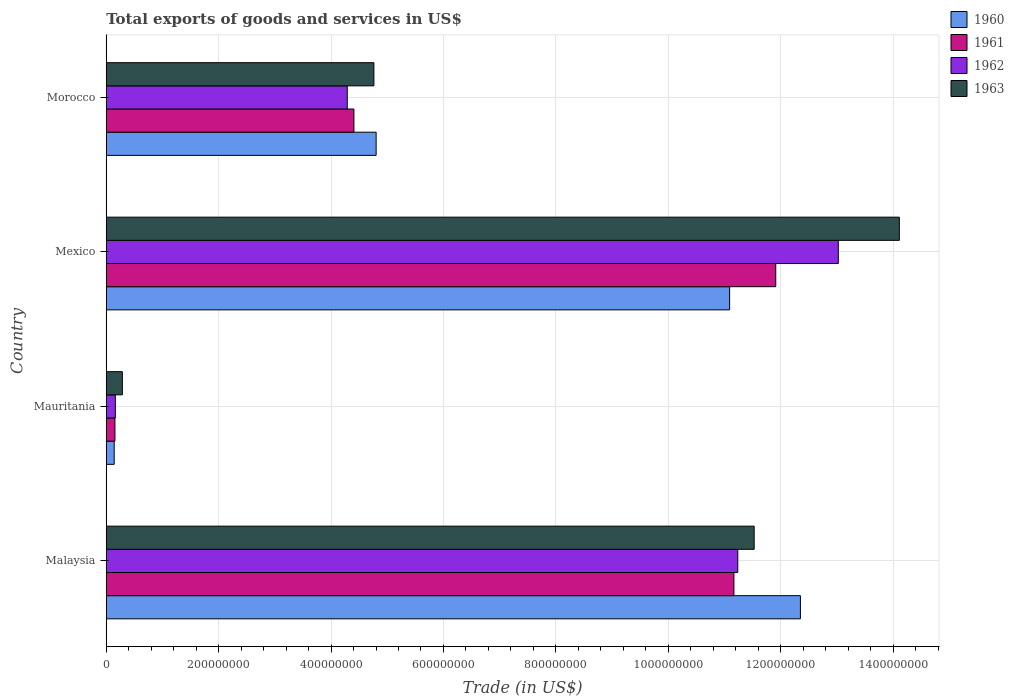How many different coloured bars are there?
Your response must be concise. 4. Are the number of bars per tick equal to the number of legend labels?
Your answer should be compact. Yes. How many bars are there on the 1st tick from the top?
Give a very brief answer. 4. What is the label of the 2nd group of bars from the top?
Give a very brief answer. Mexico. What is the total exports of goods and services in 1961 in Malaysia?
Your answer should be compact. 1.12e+09. Across all countries, what is the maximum total exports of goods and services in 1962?
Provide a succinct answer. 1.30e+09. Across all countries, what is the minimum total exports of goods and services in 1961?
Keep it short and to the point. 1.54e+07. In which country was the total exports of goods and services in 1961 maximum?
Provide a short and direct response. Mexico. In which country was the total exports of goods and services in 1963 minimum?
Your answer should be very brief. Mauritania. What is the total total exports of goods and services in 1961 in the graph?
Provide a short and direct response. 2.76e+09. What is the difference between the total exports of goods and services in 1963 in Malaysia and that in Mexico?
Provide a short and direct response. -2.58e+08. What is the difference between the total exports of goods and services in 1960 in Morocco and the total exports of goods and services in 1963 in Malaysia?
Give a very brief answer. -6.73e+08. What is the average total exports of goods and services in 1961 per country?
Your answer should be compact. 6.91e+08. What is the difference between the total exports of goods and services in 1962 and total exports of goods and services in 1960 in Mexico?
Offer a terse response. 1.93e+08. In how many countries, is the total exports of goods and services in 1962 greater than 1400000000 US$?
Keep it short and to the point. 0. What is the ratio of the total exports of goods and services in 1963 in Mexico to that in Morocco?
Give a very brief answer. 2.96. Is the difference between the total exports of goods and services in 1962 in Mauritania and Mexico greater than the difference between the total exports of goods and services in 1960 in Mauritania and Mexico?
Provide a short and direct response. No. What is the difference between the highest and the second highest total exports of goods and services in 1962?
Your answer should be compact. 1.79e+08. What is the difference between the highest and the lowest total exports of goods and services in 1961?
Offer a terse response. 1.18e+09. Is the sum of the total exports of goods and services in 1961 in Mexico and Morocco greater than the maximum total exports of goods and services in 1963 across all countries?
Keep it short and to the point. Yes. Is it the case that in every country, the sum of the total exports of goods and services in 1962 and total exports of goods and services in 1963 is greater than the sum of total exports of goods and services in 1961 and total exports of goods and services in 1960?
Offer a very short reply. No. What does the 4th bar from the top in Malaysia represents?
Your answer should be very brief. 1960. What does the 1st bar from the bottom in Malaysia represents?
Your answer should be compact. 1960. Is it the case that in every country, the sum of the total exports of goods and services in 1963 and total exports of goods and services in 1961 is greater than the total exports of goods and services in 1962?
Provide a short and direct response. Yes. How many bars are there?
Provide a succinct answer. 16. Are all the bars in the graph horizontal?
Your response must be concise. Yes. How many countries are there in the graph?
Provide a succinct answer. 4. Does the graph contain grids?
Your response must be concise. Yes. How many legend labels are there?
Make the answer very short. 4. How are the legend labels stacked?
Your answer should be compact. Vertical. What is the title of the graph?
Ensure brevity in your answer.  Total exports of goods and services in US$. Does "2005" appear as one of the legend labels in the graph?
Your response must be concise. No. What is the label or title of the X-axis?
Keep it short and to the point. Trade (in US$). What is the label or title of the Y-axis?
Provide a succinct answer. Country. What is the Trade (in US$) of 1960 in Malaysia?
Provide a succinct answer. 1.24e+09. What is the Trade (in US$) of 1961 in Malaysia?
Your response must be concise. 1.12e+09. What is the Trade (in US$) in 1962 in Malaysia?
Keep it short and to the point. 1.12e+09. What is the Trade (in US$) in 1963 in Malaysia?
Your answer should be very brief. 1.15e+09. What is the Trade (in US$) of 1960 in Mauritania?
Give a very brief answer. 1.41e+07. What is the Trade (in US$) in 1961 in Mauritania?
Your answer should be very brief. 1.54e+07. What is the Trade (in US$) in 1962 in Mauritania?
Provide a short and direct response. 1.62e+07. What is the Trade (in US$) in 1963 in Mauritania?
Offer a terse response. 2.87e+07. What is the Trade (in US$) of 1960 in Mexico?
Make the answer very short. 1.11e+09. What is the Trade (in US$) of 1961 in Mexico?
Provide a short and direct response. 1.19e+09. What is the Trade (in US$) of 1962 in Mexico?
Provide a succinct answer. 1.30e+09. What is the Trade (in US$) in 1963 in Mexico?
Provide a succinct answer. 1.41e+09. What is the Trade (in US$) in 1960 in Morocco?
Your answer should be very brief. 4.80e+08. What is the Trade (in US$) in 1961 in Morocco?
Provide a short and direct response. 4.41e+08. What is the Trade (in US$) of 1962 in Morocco?
Offer a terse response. 4.29e+08. What is the Trade (in US$) in 1963 in Morocco?
Keep it short and to the point. 4.76e+08. Across all countries, what is the maximum Trade (in US$) in 1960?
Provide a short and direct response. 1.24e+09. Across all countries, what is the maximum Trade (in US$) of 1961?
Ensure brevity in your answer.  1.19e+09. Across all countries, what is the maximum Trade (in US$) of 1962?
Provide a succinct answer. 1.30e+09. Across all countries, what is the maximum Trade (in US$) in 1963?
Make the answer very short. 1.41e+09. Across all countries, what is the minimum Trade (in US$) in 1960?
Your answer should be compact. 1.41e+07. Across all countries, what is the minimum Trade (in US$) of 1961?
Keep it short and to the point. 1.54e+07. Across all countries, what is the minimum Trade (in US$) in 1962?
Your response must be concise. 1.62e+07. Across all countries, what is the minimum Trade (in US$) in 1963?
Your answer should be very brief. 2.87e+07. What is the total Trade (in US$) of 1960 in the graph?
Keep it short and to the point. 2.84e+09. What is the total Trade (in US$) in 1961 in the graph?
Offer a very short reply. 2.76e+09. What is the total Trade (in US$) in 1962 in the graph?
Keep it short and to the point. 2.87e+09. What is the total Trade (in US$) of 1963 in the graph?
Ensure brevity in your answer.  3.07e+09. What is the difference between the Trade (in US$) of 1960 in Malaysia and that in Mauritania?
Your response must be concise. 1.22e+09. What is the difference between the Trade (in US$) of 1961 in Malaysia and that in Mauritania?
Provide a succinct answer. 1.10e+09. What is the difference between the Trade (in US$) of 1962 in Malaysia and that in Mauritania?
Provide a short and direct response. 1.11e+09. What is the difference between the Trade (in US$) in 1963 in Malaysia and that in Mauritania?
Your answer should be very brief. 1.12e+09. What is the difference between the Trade (in US$) in 1960 in Malaysia and that in Mexico?
Make the answer very short. 1.26e+08. What is the difference between the Trade (in US$) of 1961 in Malaysia and that in Mexico?
Ensure brevity in your answer.  -7.44e+07. What is the difference between the Trade (in US$) in 1962 in Malaysia and that in Mexico?
Offer a terse response. -1.79e+08. What is the difference between the Trade (in US$) in 1963 in Malaysia and that in Mexico?
Your answer should be very brief. -2.58e+08. What is the difference between the Trade (in US$) of 1960 in Malaysia and that in Morocco?
Offer a terse response. 7.55e+08. What is the difference between the Trade (in US$) of 1961 in Malaysia and that in Morocco?
Your answer should be compact. 6.76e+08. What is the difference between the Trade (in US$) of 1962 in Malaysia and that in Morocco?
Keep it short and to the point. 6.95e+08. What is the difference between the Trade (in US$) of 1963 in Malaysia and that in Morocco?
Provide a short and direct response. 6.77e+08. What is the difference between the Trade (in US$) of 1960 in Mauritania and that in Mexico?
Keep it short and to the point. -1.09e+09. What is the difference between the Trade (in US$) in 1961 in Mauritania and that in Mexico?
Your answer should be very brief. -1.18e+09. What is the difference between the Trade (in US$) in 1962 in Mauritania and that in Mexico?
Provide a succinct answer. -1.29e+09. What is the difference between the Trade (in US$) of 1963 in Mauritania and that in Mexico?
Make the answer very short. -1.38e+09. What is the difference between the Trade (in US$) in 1960 in Mauritania and that in Morocco?
Provide a succinct answer. -4.66e+08. What is the difference between the Trade (in US$) of 1961 in Mauritania and that in Morocco?
Your response must be concise. -4.25e+08. What is the difference between the Trade (in US$) in 1962 in Mauritania and that in Morocco?
Give a very brief answer. -4.13e+08. What is the difference between the Trade (in US$) of 1963 in Mauritania and that in Morocco?
Offer a very short reply. -4.48e+08. What is the difference between the Trade (in US$) in 1960 in Mexico and that in Morocco?
Your response must be concise. 6.29e+08. What is the difference between the Trade (in US$) in 1961 in Mexico and that in Morocco?
Your response must be concise. 7.51e+08. What is the difference between the Trade (in US$) in 1962 in Mexico and that in Morocco?
Make the answer very short. 8.74e+08. What is the difference between the Trade (in US$) in 1963 in Mexico and that in Morocco?
Ensure brevity in your answer.  9.35e+08. What is the difference between the Trade (in US$) in 1960 in Malaysia and the Trade (in US$) in 1961 in Mauritania?
Your answer should be very brief. 1.22e+09. What is the difference between the Trade (in US$) in 1960 in Malaysia and the Trade (in US$) in 1962 in Mauritania?
Make the answer very short. 1.22e+09. What is the difference between the Trade (in US$) of 1960 in Malaysia and the Trade (in US$) of 1963 in Mauritania?
Give a very brief answer. 1.21e+09. What is the difference between the Trade (in US$) in 1961 in Malaysia and the Trade (in US$) in 1962 in Mauritania?
Offer a very short reply. 1.10e+09. What is the difference between the Trade (in US$) of 1961 in Malaysia and the Trade (in US$) of 1963 in Mauritania?
Give a very brief answer. 1.09e+09. What is the difference between the Trade (in US$) in 1962 in Malaysia and the Trade (in US$) in 1963 in Mauritania?
Your answer should be very brief. 1.09e+09. What is the difference between the Trade (in US$) in 1960 in Malaysia and the Trade (in US$) in 1961 in Mexico?
Provide a short and direct response. 4.39e+07. What is the difference between the Trade (in US$) in 1960 in Malaysia and the Trade (in US$) in 1962 in Mexico?
Offer a terse response. -6.74e+07. What is the difference between the Trade (in US$) of 1960 in Malaysia and the Trade (in US$) of 1963 in Mexico?
Give a very brief answer. -1.76e+08. What is the difference between the Trade (in US$) of 1961 in Malaysia and the Trade (in US$) of 1962 in Mexico?
Provide a short and direct response. -1.86e+08. What is the difference between the Trade (in US$) of 1961 in Malaysia and the Trade (in US$) of 1963 in Mexico?
Give a very brief answer. -2.94e+08. What is the difference between the Trade (in US$) of 1962 in Malaysia and the Trade (in US$) of 1963 in Mexico?
Ensure brevity in your answer.  -2.87e+08. What is the difference between the Trade (in US$) of 1960 in Malaysia and the Trade (in US$) of 1961 in Morocco?
Make the answer very short. 7.94e+08. What is the difference between the Trade (in US$) of 1960 in Malaysia and the Trade (in US$) of 1962 in Morocco?
Give a very brief answer. 8.06e+08. What is the difference between the Trade (in US$) in 1960 in Malaysia and the Trade (in US$) in 1963 in Morocco?
Make the answer very short. 7.59e+08. What is the difference between the Trade (in US$) in 1961 in Malaysia and the Trade (in US$) in 1962 in Morocco?
Keep it short and to the point. 6.88e+08. What is the difference between the Trade (in US$) of 1961 in Malaysia and the Trade (in US$) of 1963 in Morocco?
Provide a short and direct response. 6.41e+08. What is the difference between the Trade (in US$) in 1962 in Malaysia and the Trade (in US$) in 1963 in Morocco?
Offer a very short reply. 6.47e+08. What is the difference between the Trade (in US$) in 1960 in Mauritania and the Trade (in US$) in 1961 in Mexico?
Keep it short and to the point. -1.18e+09. What is the difference between the Trade (in US$) in 1960 in Mauritania and the Trade (in US$) in 1962 in Mexico?
Your answer should be compact. -1.29e+09. What is the difference between the Trade (in US$) of 1960 in Mauritania and the Trade (in US$) of 1963 in Mexico?
Make the answer very short. -1.40e+09. What is the difference between the Trade (in US$) of 1961 in Mauritania and the Trade (in US$) of 1962 in Mexico?
Provide a succinct answer. -1.29e+09. What is the difference between the Trade (in US$) in 1961 in Mauritania and the Trade (in US$) in 1963 in Mexico?
Keep it short and to the point. -1.40e+09. What is the difference between the Trade (in US$) of 1962 in Mauritania and the Trade (in US$) of 1963 in Mexico?
Provide a short and direct response. -1.39e+09. What is the difference between the Trade (in US$) in 1960 in Mauritania and the Trade (in US$) in 1961 in Morocco?
Make the answer very short. -4.27e+08. What is the difference between the Trade (in US$) of 1960 in Mauritania and the Trade (in US$) of 1962 in Morocco?
Keep it short and to the point. -4.15e+08. What is the difference between the Trade (in US$) of 1960 in Mauritania and the Trade (in US$) of 1963 in Morocco?
Provide a short and direct response. -4.62e+08. What is the difference between the Trade (in US$) in 1961 in Mauritania and the Trade (in US$) in 1962 in Morocco?
Make the answer very short. -4.13e+08. What is the difference between the Trade (in US$) in 1961 in Mauritania and the Trade (in US$) in 1963 in Morocco?
Ensure brevity in your answer.  -4.61e+08. What is the difference between the Trade (in US$) of 1962 in Mauritania and the Trade (in US$) of 1963 in Morocco?
Your answer should be very brief. -4.60e+08. What is the difference between the Trade (in US$) of 1960 in Mexico and the Trade (in US$) of 1961 in Morocco?
Make the answer very short. 6.68e+08. What is the difference between the Trade (in US$) of 1960 in Mexico and the Trade (in US$) of 1962 in Morocco?
Make the answer very short. 6.80e+08. What is the difference between the Trade (in US$) in 1960 in Mexico and the Trade (in US$) in 1963 in Morocco?
Your response must be concise. 6.33e+08. What is the difference between the Trade (in US$) in 1961 in Mexico and the Trade (in US$) in 1962 in Morocco?
Your response must be concise. 7.62e+08. What is the difference between the Trade (in US$) of 1961 in Mexico and the Trade (in US$) of 1963 in Morocco?
Keep it short and to the point. 7.15e+08. What is the difference between the Trade (in US$) in 1962 in Mexico and the Trade (in US$) in 1963 in Morocco?
Your answer should be compact. 8.26e+08. What is the average Trade (in US$) of 1960 per country?
Give a very brief answer. 7.10e+08. What is the average Trade (in US$) of 1961 per country?
Your answer should be compact. 6.91e+08. What is the average Trade (in US$) in 1962 per country?
Offer a very short reply. 7.18e+08. What is the average Trade (in US$) in 1963 per country?
Ensure brevity in your answer.  7.67e+08. What is the difference between the Trade (in US$) of 1960 and Trade (in US$) of 1961 in Malaysia?
Give a very brief answer. 1.18e+08. What is the difference between the Trade (in US$) in 1960 and Trade (in US$) in 1962 in Malaysia?
Provide a succinct answer. 1.11e+08. What is the difference between the Trade (in US$) of 1960 and Trade (in US$) of 1963 in Malaysia?
Keep it short and to the point. 8.23e+07. What is the difference between the Trade (in US$) of 1961 and Trade (in US$) of 1962 in Malaysia?
Provide a succinct answer. -6.88e+06. What is the difference between the Trade (in US$) in 1961 and Trade (in US$) in 1963 in Malaysia?
Offer a terse response. -3.60e+07. What is the difference between the Trade (in US$) of 1962 and Trade (in US$) of 1963 in Malaysia?
Make the answer very short. -2.92e+07. What is the difference between the Trade (in US$) in 1960 and Trade (in US$) in 1961 in Mauritania?
Give a very brief answer. -1.31e+06. What is the difference between the Trade (in US$) of 1960 and Trade (in US$) of 1962 in Mauritania?
Give a very brief answer. -2.02e+06. What is the difference between the Trade (in US$) of 1960 and Trade (in US$) of 1963 in Mauritania?
Keep it short and to the point. -1.45e+07. What is the difference between the Trade (in US$) of 1961 and Trade (in US$) of 1962 in Mauritania?
Provide a short and direct response. -7.07e+05. What is the difference between the Trade (in US$) in 1961 and Trade (in US$) in 1963 in Mauritania?
Make the answer very short. -1.32e+07. What is the difference between the Trade (in US$) in 1962 and Trade (in US$) in 1963 in Mauritania?
Offer a terse response. -1.25e+07. What is the difference between the Trade (in US$) of 1960 and Trade (in US$) of 1961 in Mexico?
Keep it short and to the point. -8.21e+07. What is the difference between the Trade (in US$) in 1960 and Trade (in US$) in 1962 in Mexico?
Your answer should be compact. -1.93e+08. What is the difference between the Trade (in US$) of 1960 and Trade (in US$) of 1963 in Mexico?
Offer a terse response. -3.02e+08. What is the difference between the Trade (in US$) of 1961 and Trade (in US$) of 1962 in Mexico?
Your answer should be compact. -1.11e+08. What is the difference between the Trade (in US$) of 1961 and Trade (in US$) of 1963 in Mexico?
Your answer should be very brief. -2.20e+08. What is the difference between the Trade (in US$) in 1962 and Trade (in US$) in 1963 in Mexico?
Ensure brevity in your answer.  -1.09e+08. What is the difference between the Trade (in US$) of 1960 and Trade (in US$) of 1961 in Morocco?
Give a very brief answer. 3.95e+07. What is the difference between the Trade (in US$) in 1960 and Trade (in US$) in 1962 in Morocco?
Provide a short and direct response. 5.14e+07. What is the difference between the Trade (in US$) in 1960 and Trade (in US$) in 1963 in Morocco?
Ensure brevity in your answer.  3.95e+06. What is the difference between the Trade (in US$) in 1961 and Trade (in US$) in 1962 in Morocco?
Give a very brief answer. 1.19e+07. What is the difference between the Trade (in US$) of 1961 and Trade (in US$) of 1963 in Morocco?
Ensure brevity in your answer.  -3.56e+07. What is the difference between the Trade (in US$) of 1962 and Trade (in US$) of 1963 in Morocco?
Ensure brevity in your answer.  -4.74e+07. What is the ratio of the Trade (in US$) in 1960 in Malaysia to that in Mauritania?
Offer a terse response. 87.37. What is the ratio of the Trade (in US$) in 1961 in Malaysia to that in Mauritania?
Make the answer very short. 72.29. What is the ratio of the Trade (in US$) of 1962 in Malaysia to that in Mauritania?
Offer a very short reply. 69.56. What is the ratio of the Trade (in US$) in 1963 in Malaysia to that in Mauritania?
Offer a terse response. 40.2. What is the ratio of the Trade (in US$) in 1960 in Malaysia to that in Mexico?
Offer a terse response. 1.11. What is the ratio of the Trade (in US$) in 1962 in Malaysia to that in Mexico?
Keep it short and to the point. 0.86. What is the ratio of the Trade (in US$) in 1963 in Malaysia to that in Mexico?
Your answer should be compact. 0.82. What is the ratio of the Trade (in US$) in 1960 in Malaysia to that in Morocco?
Offer a very short reply. 2.57. What is the ratio of the Trade (in US$) of 1961 in Malaysia to that in Morocco?
Ensure brevity in your answer.  2.53. What is the ratio of the Trade (in US$) in 1962 in Malaysia to that in Morocco?
Provide a succinct answer. 2.62. What is the ratio of the Trade (in US$) in 1963 in Malaysia to that in Morocco?
Ensure brevity in your answer.  2.42. What is the ratio of the Trade (in US$) in 1960 in Mauritania to that in Mexico?
Your response must be concise. 0.01. What is the ratio of the Trade (in US$) of 1961 in Mauritania to that in Mexico?
Make the answer very short. 0.01. What is the ratio of the Trade (in US$) in 1962 in Mauritania to that in Mexico?
Your answer should be very brief. 0.01. What is the ratio of the Trade (in US$) of 1963 in Mauritania to that in Mexico?
Offer a terse response. 0.02. What is the ratio of the Trade (in US$) of 1960 in Mauritania to that in Morocco?
Offer a very short reply. 0.03. What is the ratio of the Trade (in US$) of 1961 in Mauritania to that in Morocco?
Offer a very short reply. 0.04. What is the ratio of the Trade (in US$) of 1962 in Mauritania to that in Morocco?
Your response must be concise. 0.04. What is the ratio of the Trade (in US$) of 1963 in Mauritania to that in Morocco?
Make the answer very short. 0.06. What is the ratio of the Trade (in US$) in 1960 in Mexico to that in Morocco?
Keep it short and to the point. 2.31. What is the ratio of the Trade (in US$) of 1961 in Mexico to that in Morocco?
Make the answer very short. 2.7. What is the ratio of the Trade (in US$) in 1962 in Mexico to that in Morocco?
Keep it short and to the point. 3.04. What is the ratio of the Trade (in US$) of 1963 in Mexico to that in Morocco?
Keep it short and to the point. 2.96. What is the difference between the highest and the second highest Trade (in US$) of 1960?
Offer a terse response. 1.26e+08. What is the difference between the highest and the second highest Trade (in US$) of 1961?
Your response must be concise. 7.44e+07. What is the difference between the highest and the second highest Trade (in US$) of 1962?
Your answer should be compact. 1.79e+08. What is the difference between the highest and the second highest Trade (in US$) of 1963?
Offer a very short reply. 2.58e+08. What is the difference between the highest and the lowest Trade (in US$) in 1960?
Your response must be concise. 1.22e+09. What is the difference between the highest and the lowest Trade (in US$) in 1961?
Your answer should be very brief. 1.18e+09. What is the difference between the highest and the lowest Trade (in US$) in 1962?
Your answer should be very brief. 1.29e+09. What is the difference between the highest and the lowest Trade (in US$) of 1963?
Provide a succinct answer. 1.38e+09. 